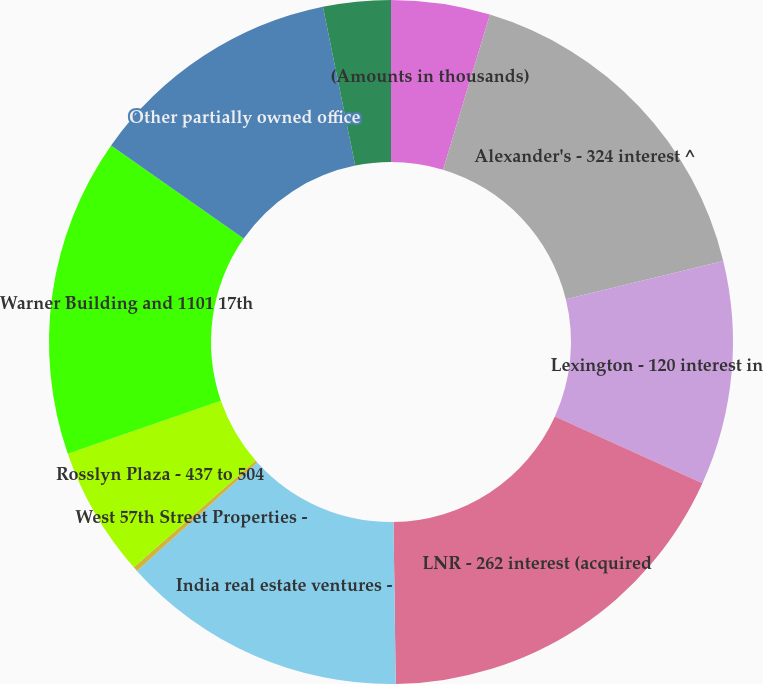<chart> <loc_0><loc_0><loc_500><loc_500><pie_chart><fcel>(Amounts in thousands)<fcel>Alexander's - 324 interest ^<fcel>Lexington - 120 interest in<fcel>LNR - 262 interest (acquired<fcel>India real estate ventures -<fcel>West 57th Street Properties -<fcel>Rosslyn Plaza - 437 to 504<fcel>Warner Building and 1101 17th<fcel>Other partially owned office<fcel>Verde Realty Operating<nl><fcel>4.67%<fcel>16.52%<fcel>10.59%<fcel>18.0%<fcel>13.55%<fcel>0.22%<fcel>6.15%<fcel>15.04%<fcel>12.07%<fcel>3.19%<nl></chart> 